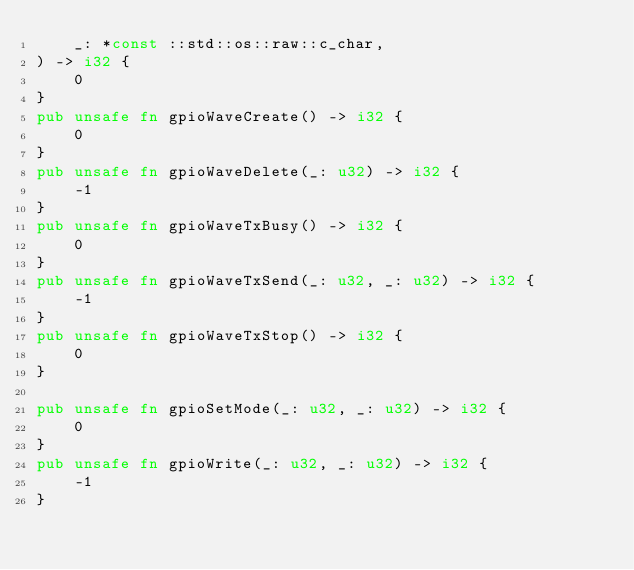Convert code to text. <code><loc_0><loc_0><loc_500><loc_500><_Rust_>    _: *const ::std::os::raw::c_char,
) -> i32 {
    0
}
pub unsafe fn gpioWaveCreate() -> i32 {
    0
}
pub unsafe fn gpioWaveDelete(_: u32) -> i32 {
    -1
}
pub unsafe fn gpioWaveTxBusy() -> i32 {
    0
}
pub unsafe fn gpioWaveTxSend(_: u32, _: u32) -> i32 {
    -1
}
pub unsafe fn gpioWaveTxStop() -> i32 {
    0
}

pub unsafe fn gpioSetMode(_: u32, _: u32) -> i32 {
    0
}
pub unsafe fn gpioWrite(_: u32, _: u32) -> i32 {
    -1
}
</code> 